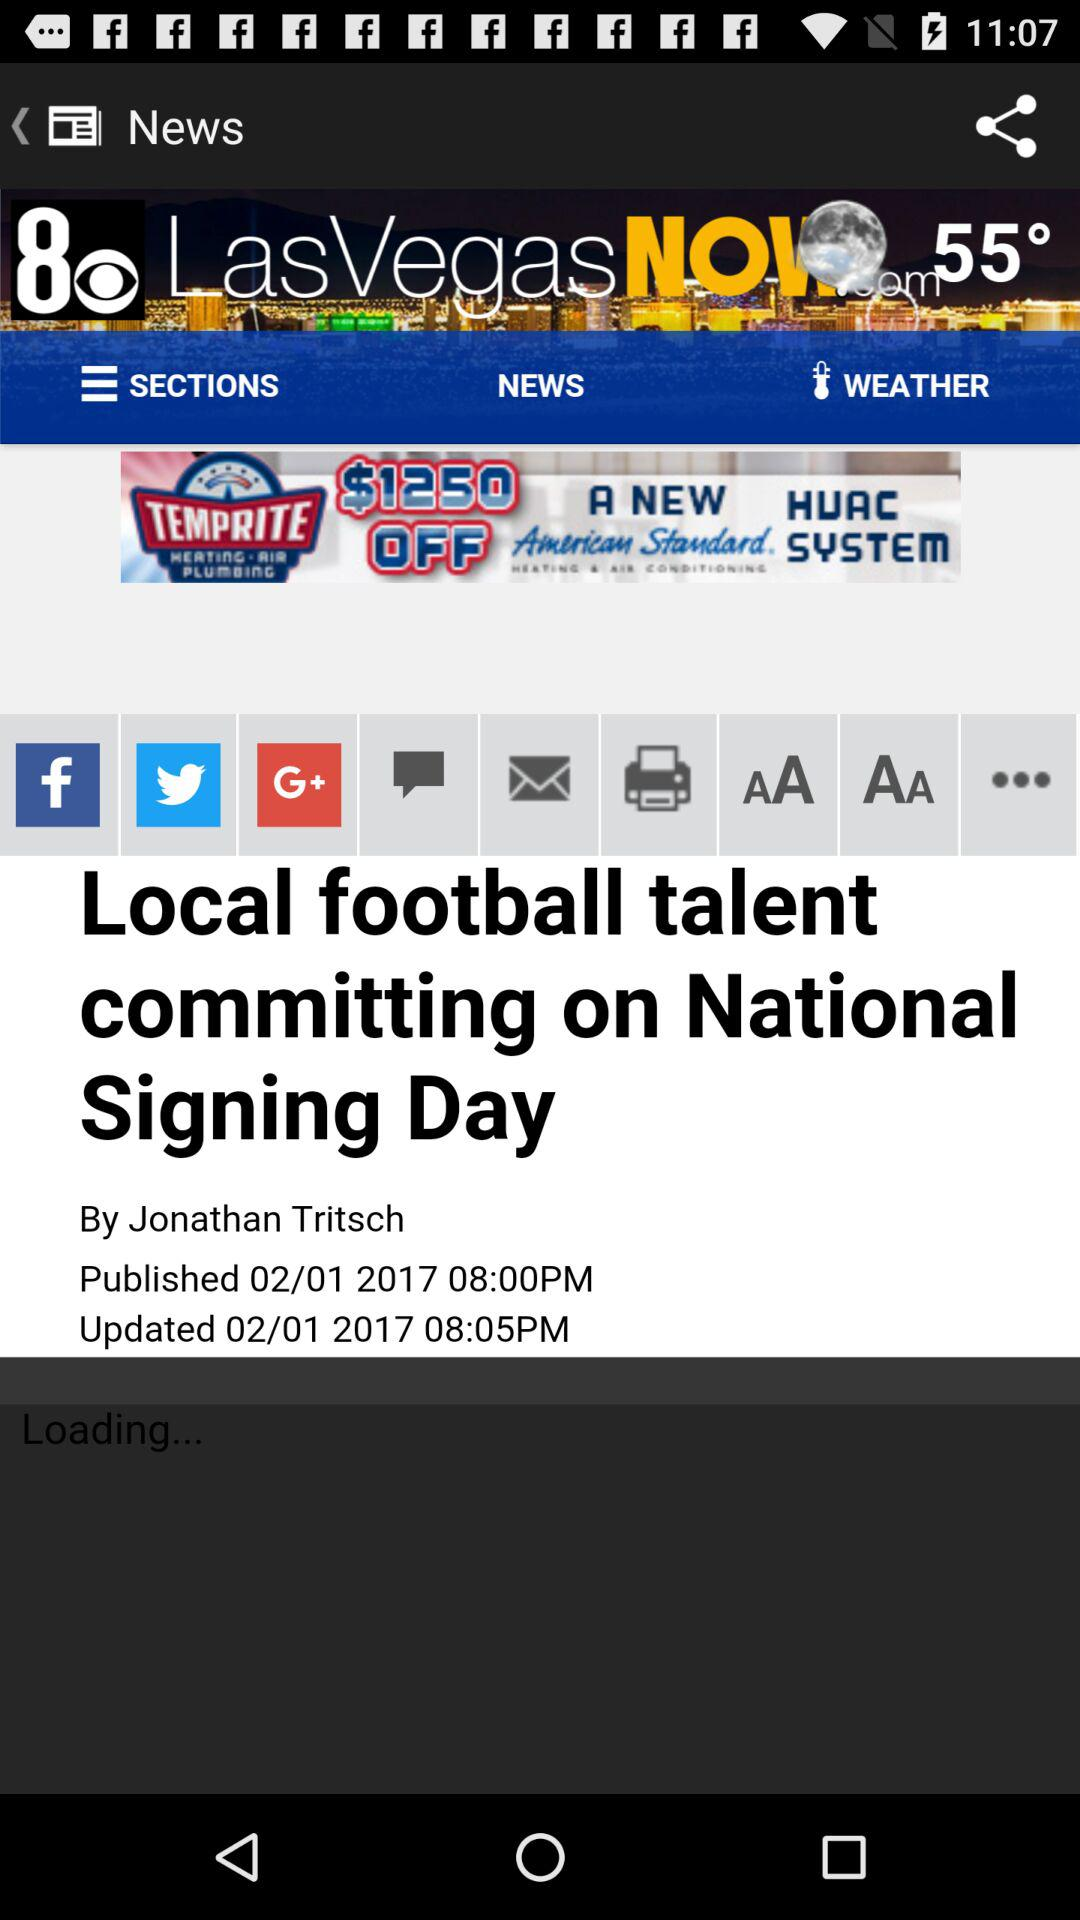When was it last updated? It was last updated on February 1, 2017 at 8:05 PM. 